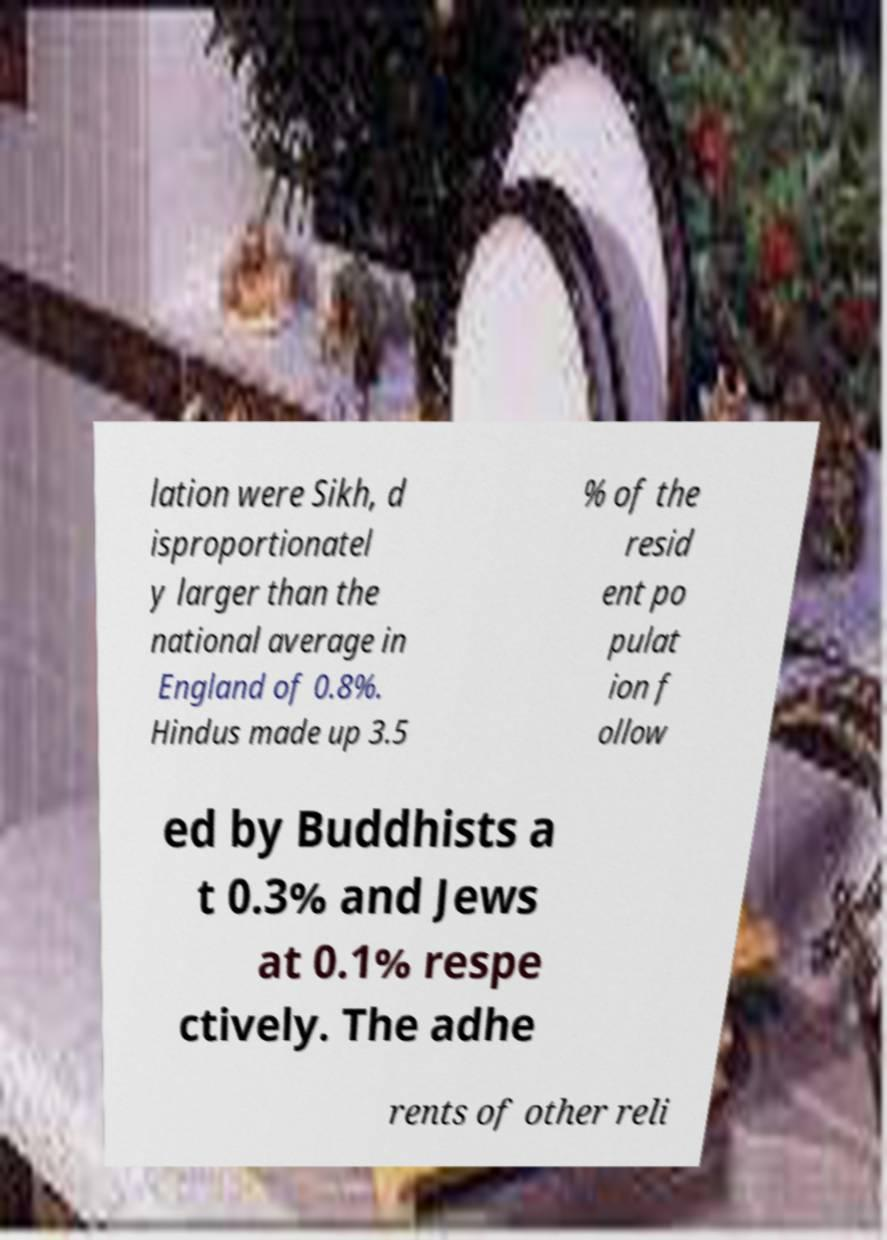What messages or text are displayed in this image? I need them in a readable, typed format. lation were Sikh, d isproportionatel y larger than the national average in England of 0.8%. Hindus made up 3.5 % of the resid ent po pulat ion f ollow ed by Buddhists a t 0.3% and Jews at 0.1% respe ctively. The adhe rents of other reli 